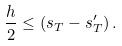Convert formula to latex. <formula><loc_0><loc_0><loc_500><loc_500>\frac { h } { 2 } \leq \left ( s _ { T } - s _ { T } ^ { \prime } \right ) .</formula> 